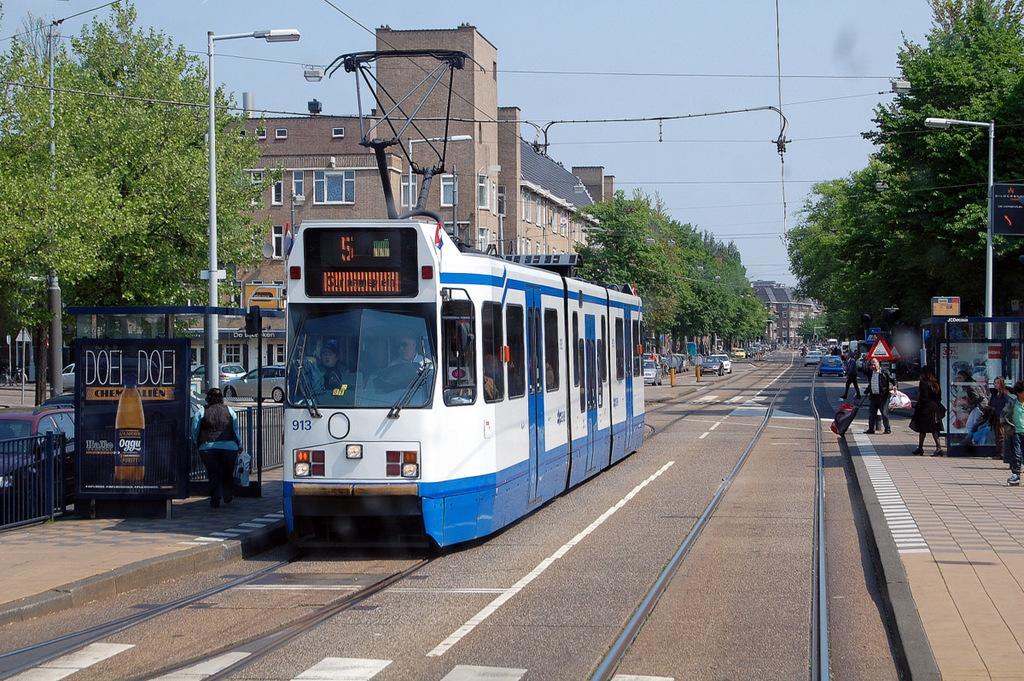Could you give a brief overview of what you see in this image? In this picture we can see train on a railway track and aside to this we have footpath where some people are walking and some are waiting for train and we have pole, light and trees and at left side we have same footpath with fence and a banner where woman is walking and in background we can see building with glass windows, sky and some cars. 